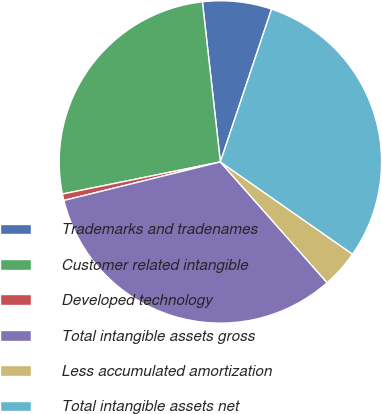<chart> <loc_0><loc_0><loc_500><loc_500><pie_chart><fcel>Trademarks and tradenames<fcel>Customer related intangible<fcel>Developed technology<fcel>Total intangible assets gross<fcel>Less accumulated amortization<fcel>Total intangible assets net<nl><fcel>6.92%<fcel>26.41%<fcel>0.65%<fcel>32.68%<fcel>3.78%<fcel>29.55%<nl></chart> 